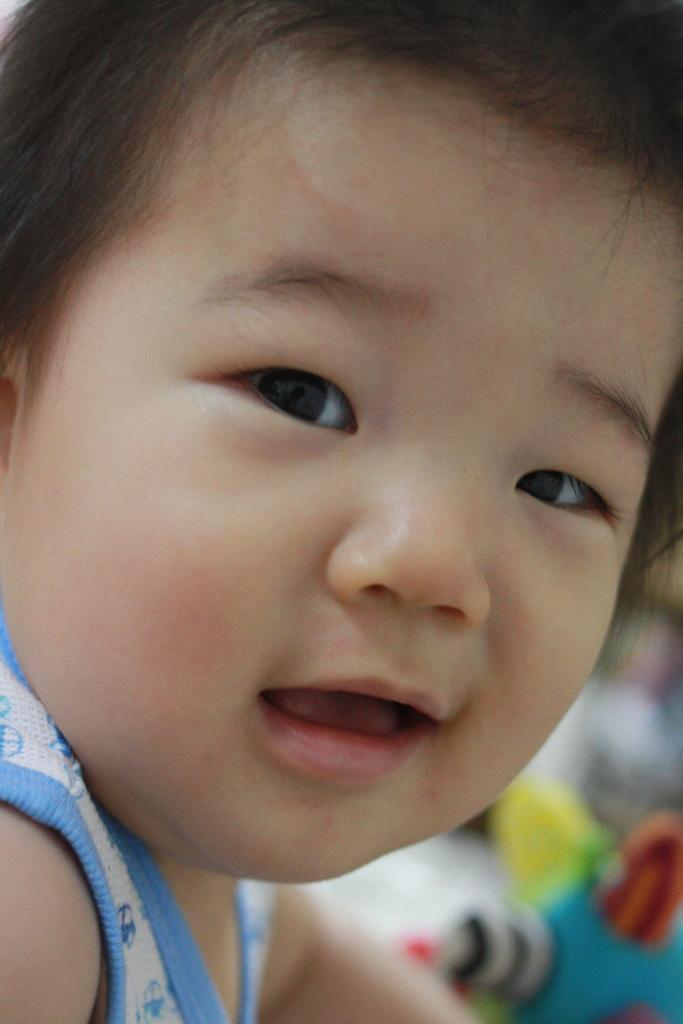What is the main subject of the image? There is a baby in the image. Can you describe the background of the image? The background of the image is blurred. How many eggs are visible in the image? There are no eggs present in the image. What type of vegetable is being used to stop the baby from crawling in the image? There is no vegetable or any object being used to stop the baby from crawling in the image. 